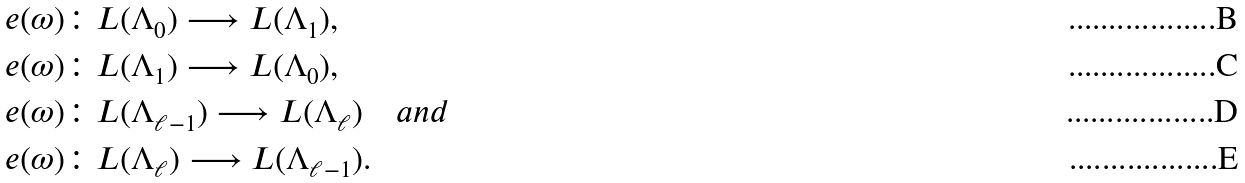<formula> <loc_0><loc_0><loc_500><loc_500>e ( \omega ) & \colon L ( \Lambda _ { 0 } ) \longrightarrow L ( \Lambda _ { 1 } ) , \\ e ( \omega ) & \colon L ( \Lambda _ { 1 } ) \longrightarrow L ( \Lambda _ { 0 } ) , \\ e ( \omega ) & \colon L ( \Lambda _ { \ell - 1 } ) \longrightarrow L ( \Lambda _ { \ell } ) \quad a n d \\ e ( \omega ) & \colon L ( \Lambda _ { \ell } ) \longrightarrow L ( \Lambda _ { \ell - 1 } ) .</formula> 